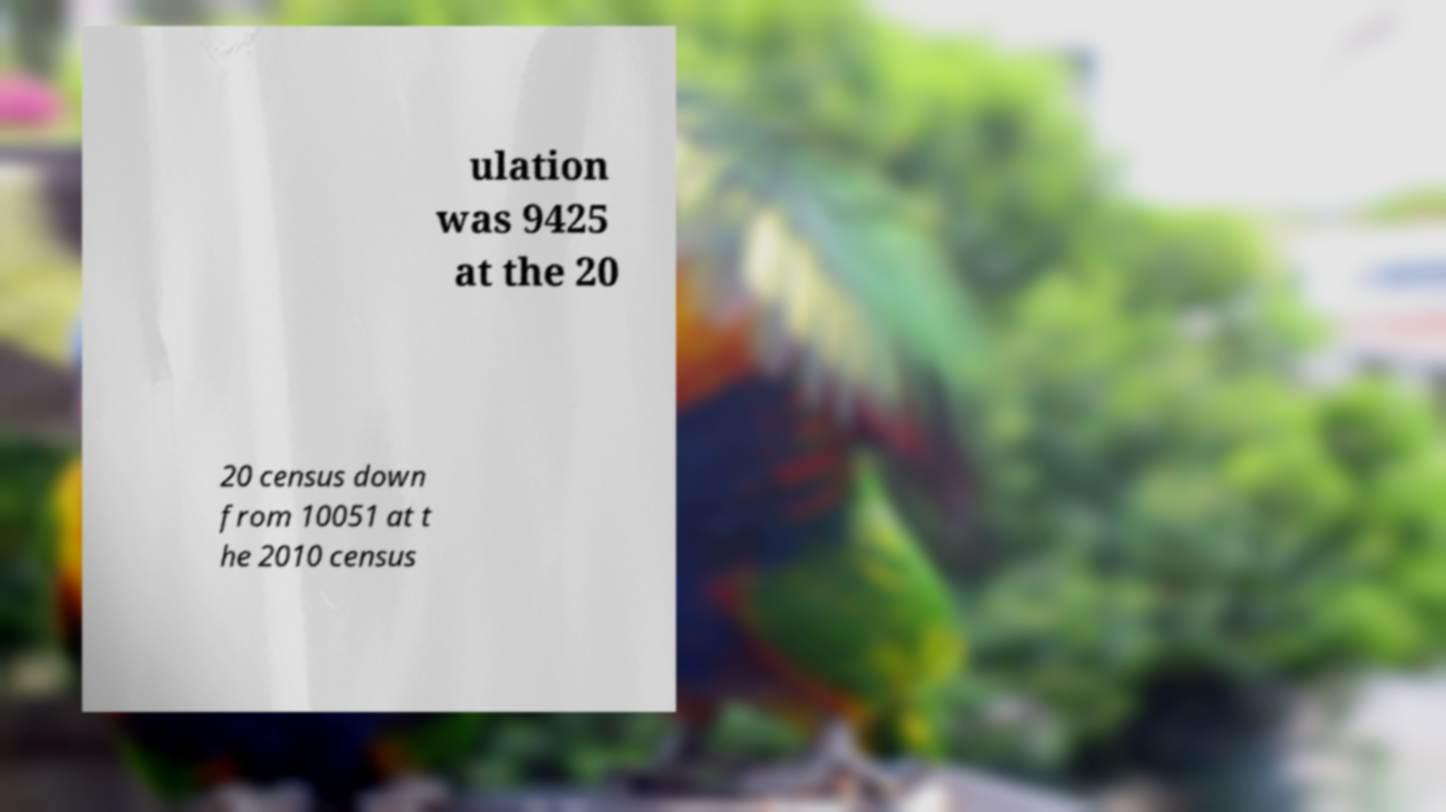What messages or text are displayed in this image? I need them in a readable, typed format. ulation was 9425 at the 20 20 census down from 10051 at t he 2010 census 